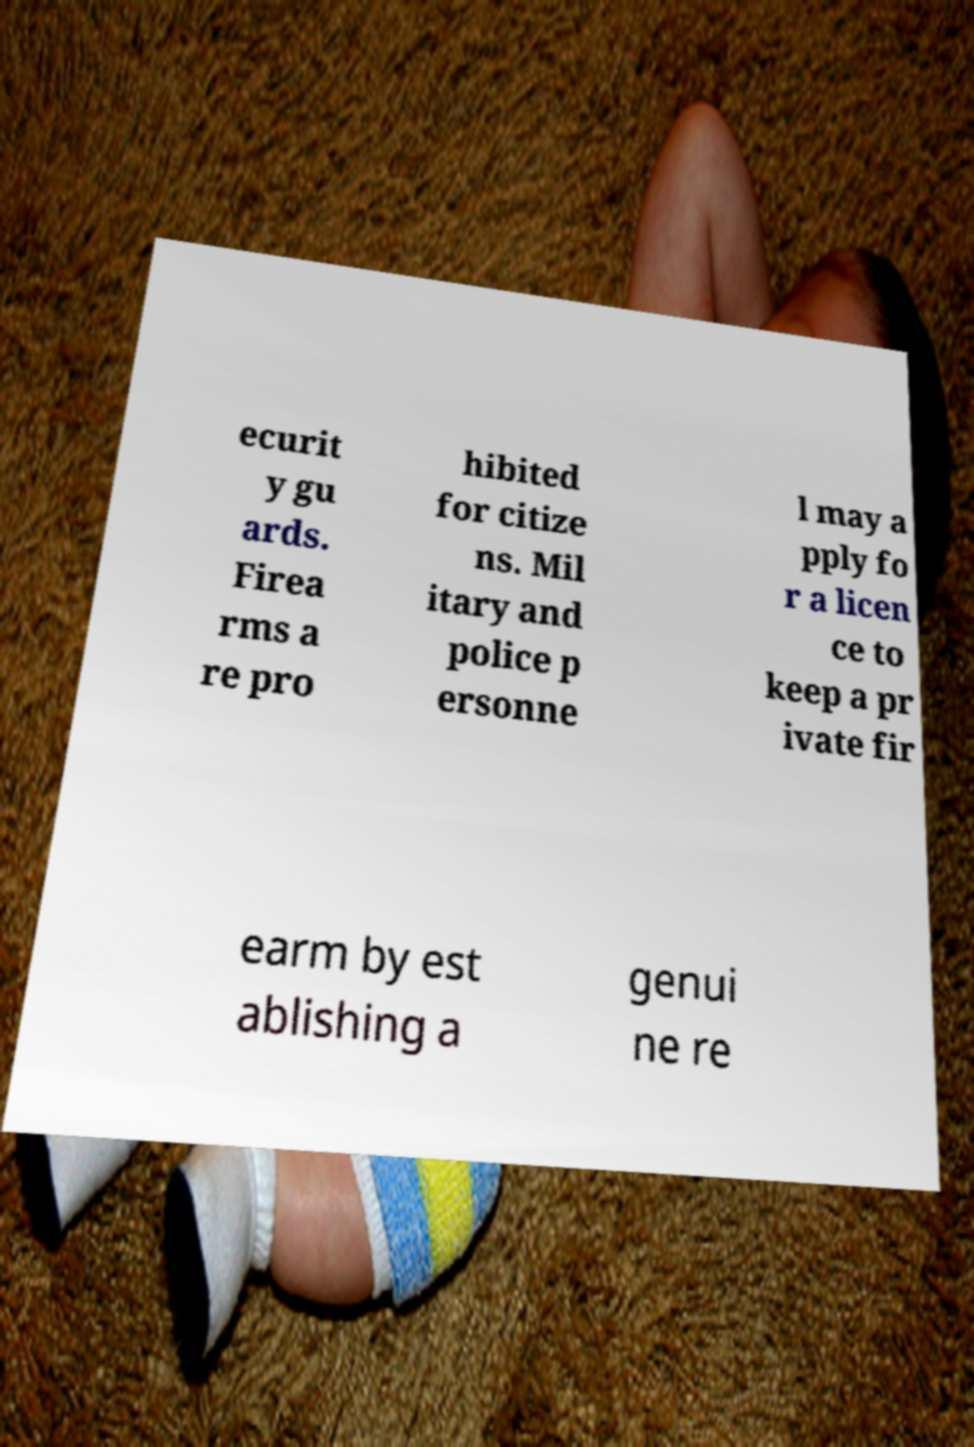I need the written content from this picture converted into text. Can you do that? ecurit y gu ards. Firea rms a re pro hibited for citize ns. Mil itary and police p ersonne l may a pply fo r a licen ce to keep a pr ivate fir earm by est ablishing a genui ne re 